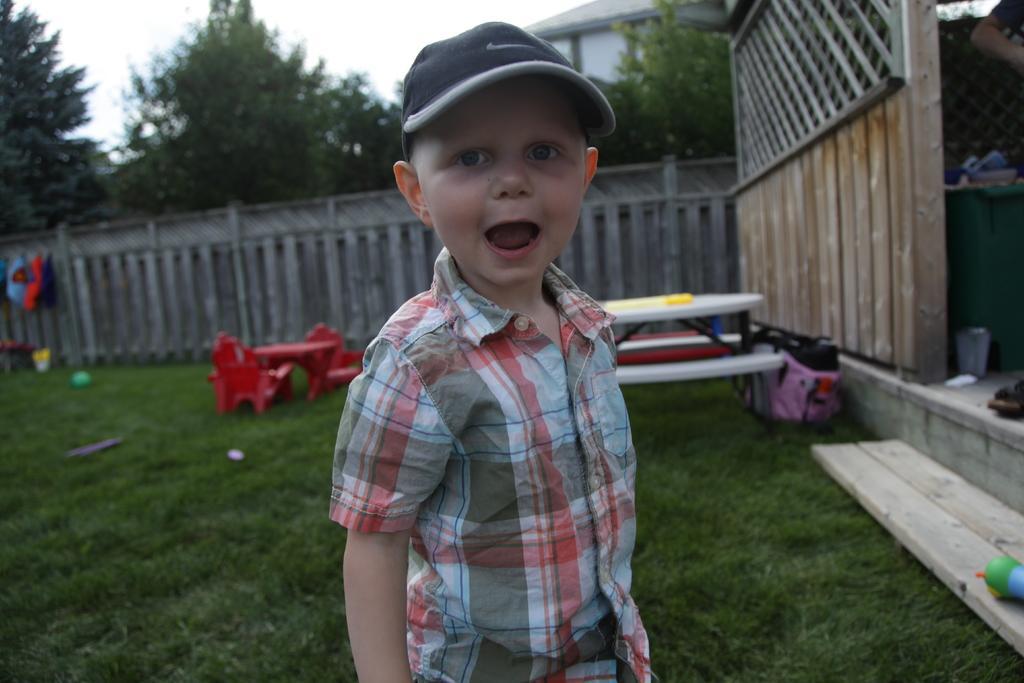Please provide a concise description of this image. In this picture we can see a boy and in the background we can see a fence, grass, building, trees, sky and some objects. 